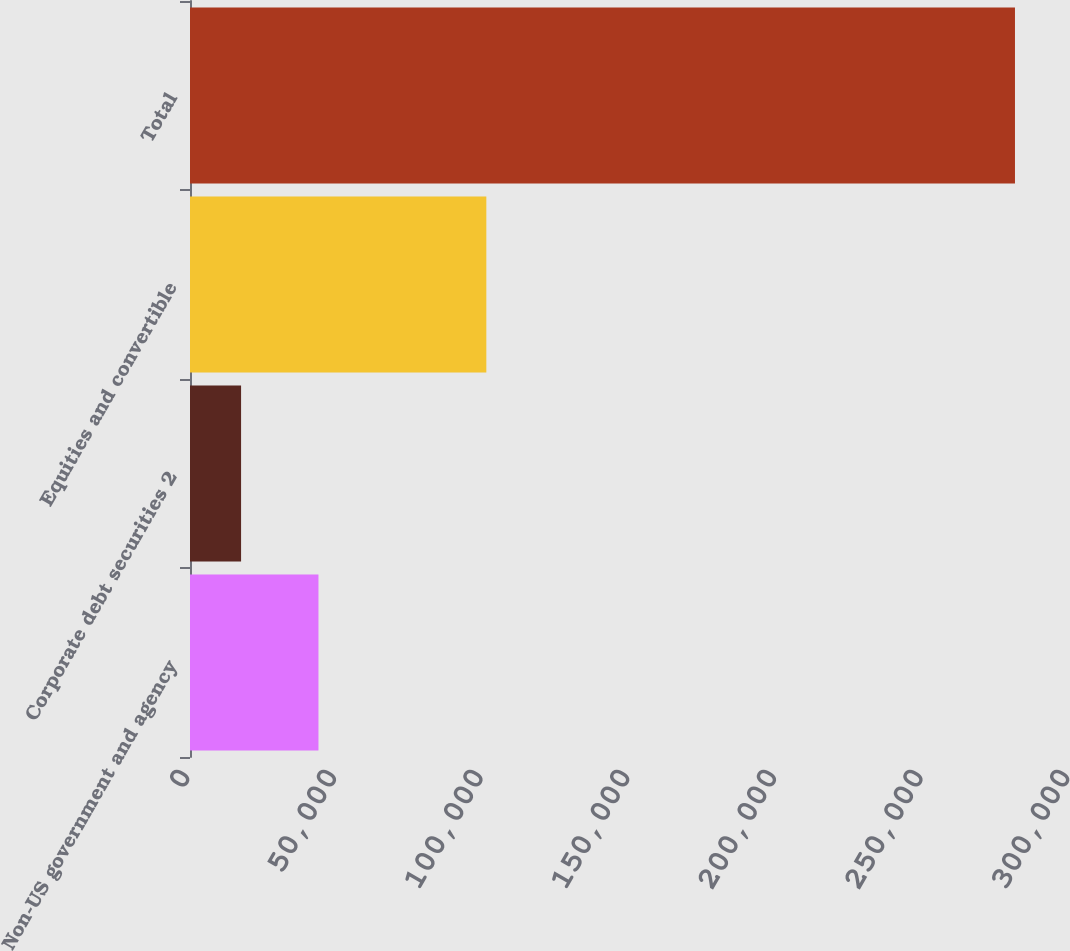Convert chart. <chart><loc_0><loc_0><loc_500><loc_500><bar_chart><fcel>Non-US government and agency<fcel>Corporate debt securities 2<fcel>Equities and convertible<fcel>Total<nl><fcel>43795<fcel>17412<fcel>101024<fcel>281242<nl></chart> 